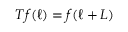<formula> <loc_0><loc_0><loc_500><loc_500>T f ( \ell ) = f ( \ell + L )</formula> 